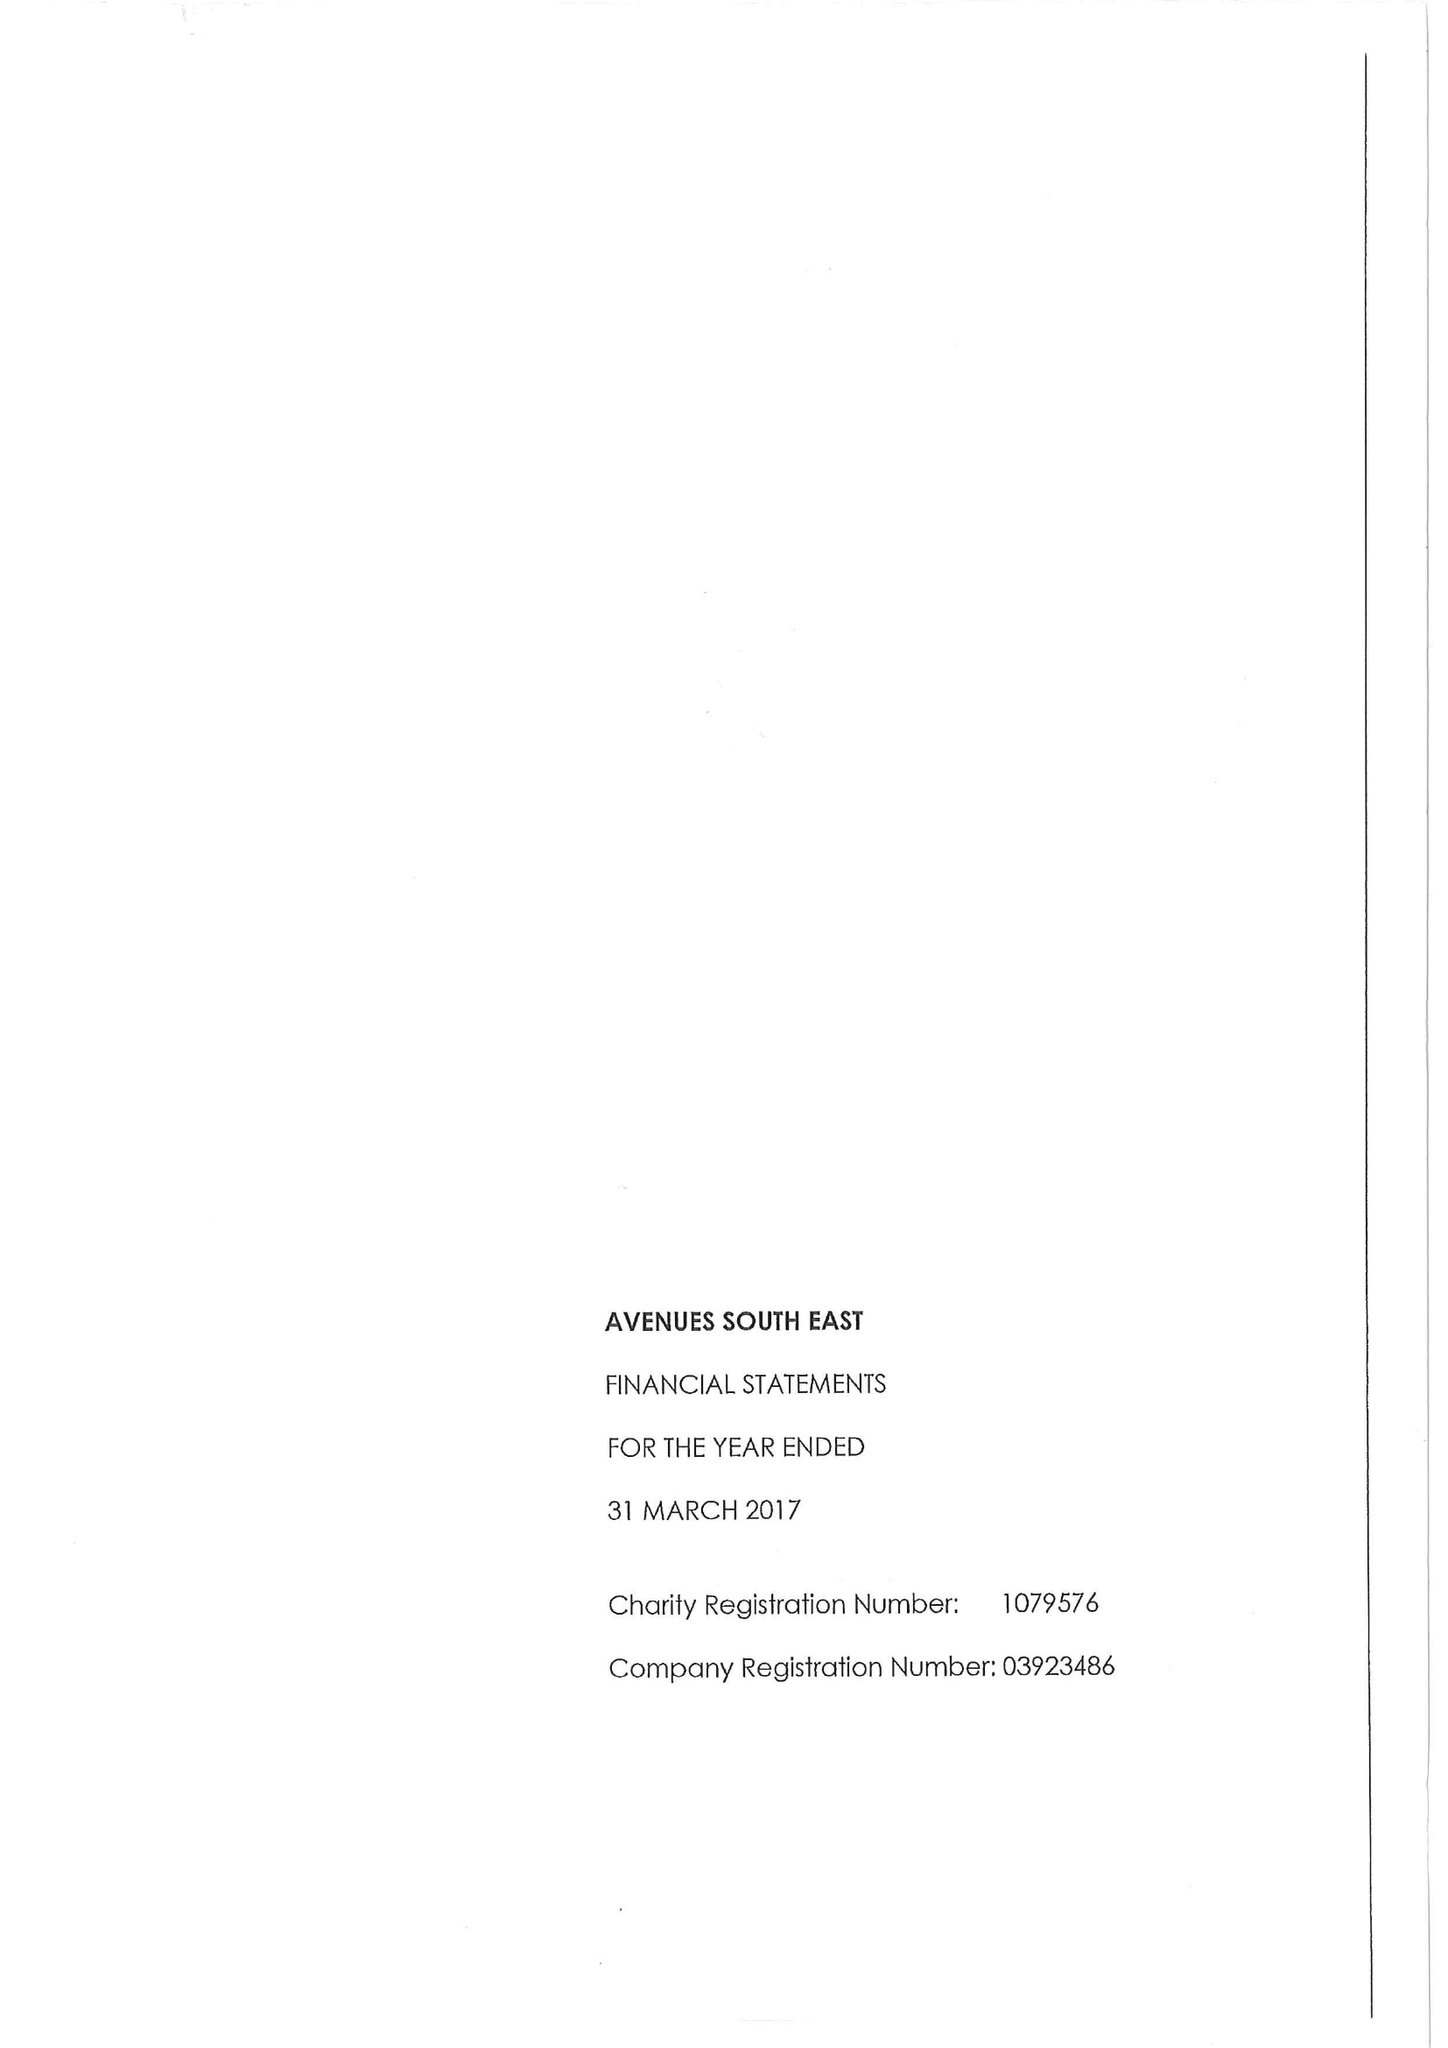What is the value for the address__post_town?
Answer the question using a single word or phrase. SIDCUP 